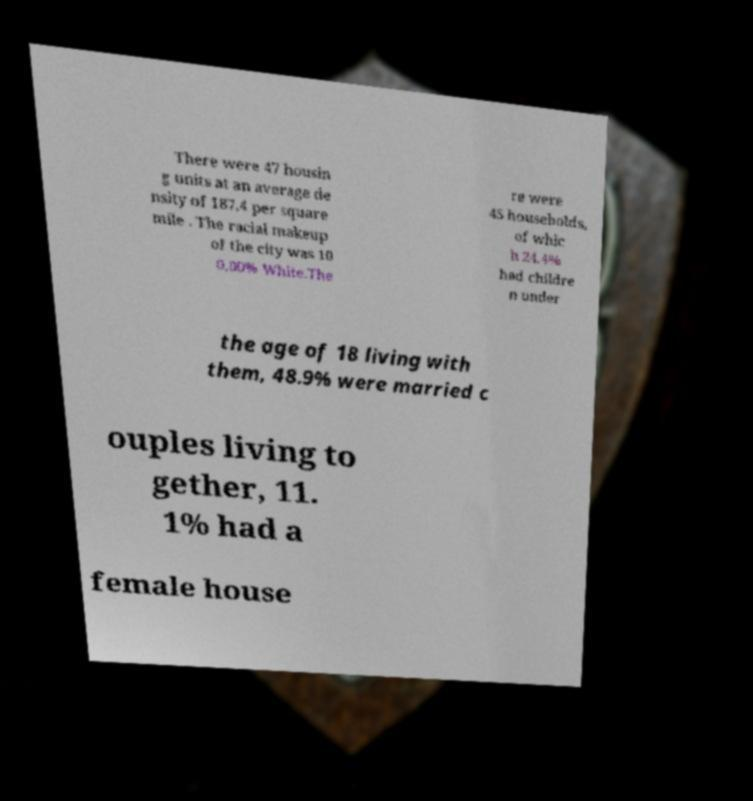For documentation purposes, I need the text within this image transcribed. Could you provide that? There were 47 housin g units at an average de nsity of 187.4 per square mile . The racial makeup of the city was 10 0.00% White.The re were 45 households, of whic h 24.4% had childre n under the age of 18 living with them, 48.9% were married c ouples living to gether, 11. 1% had a female house 